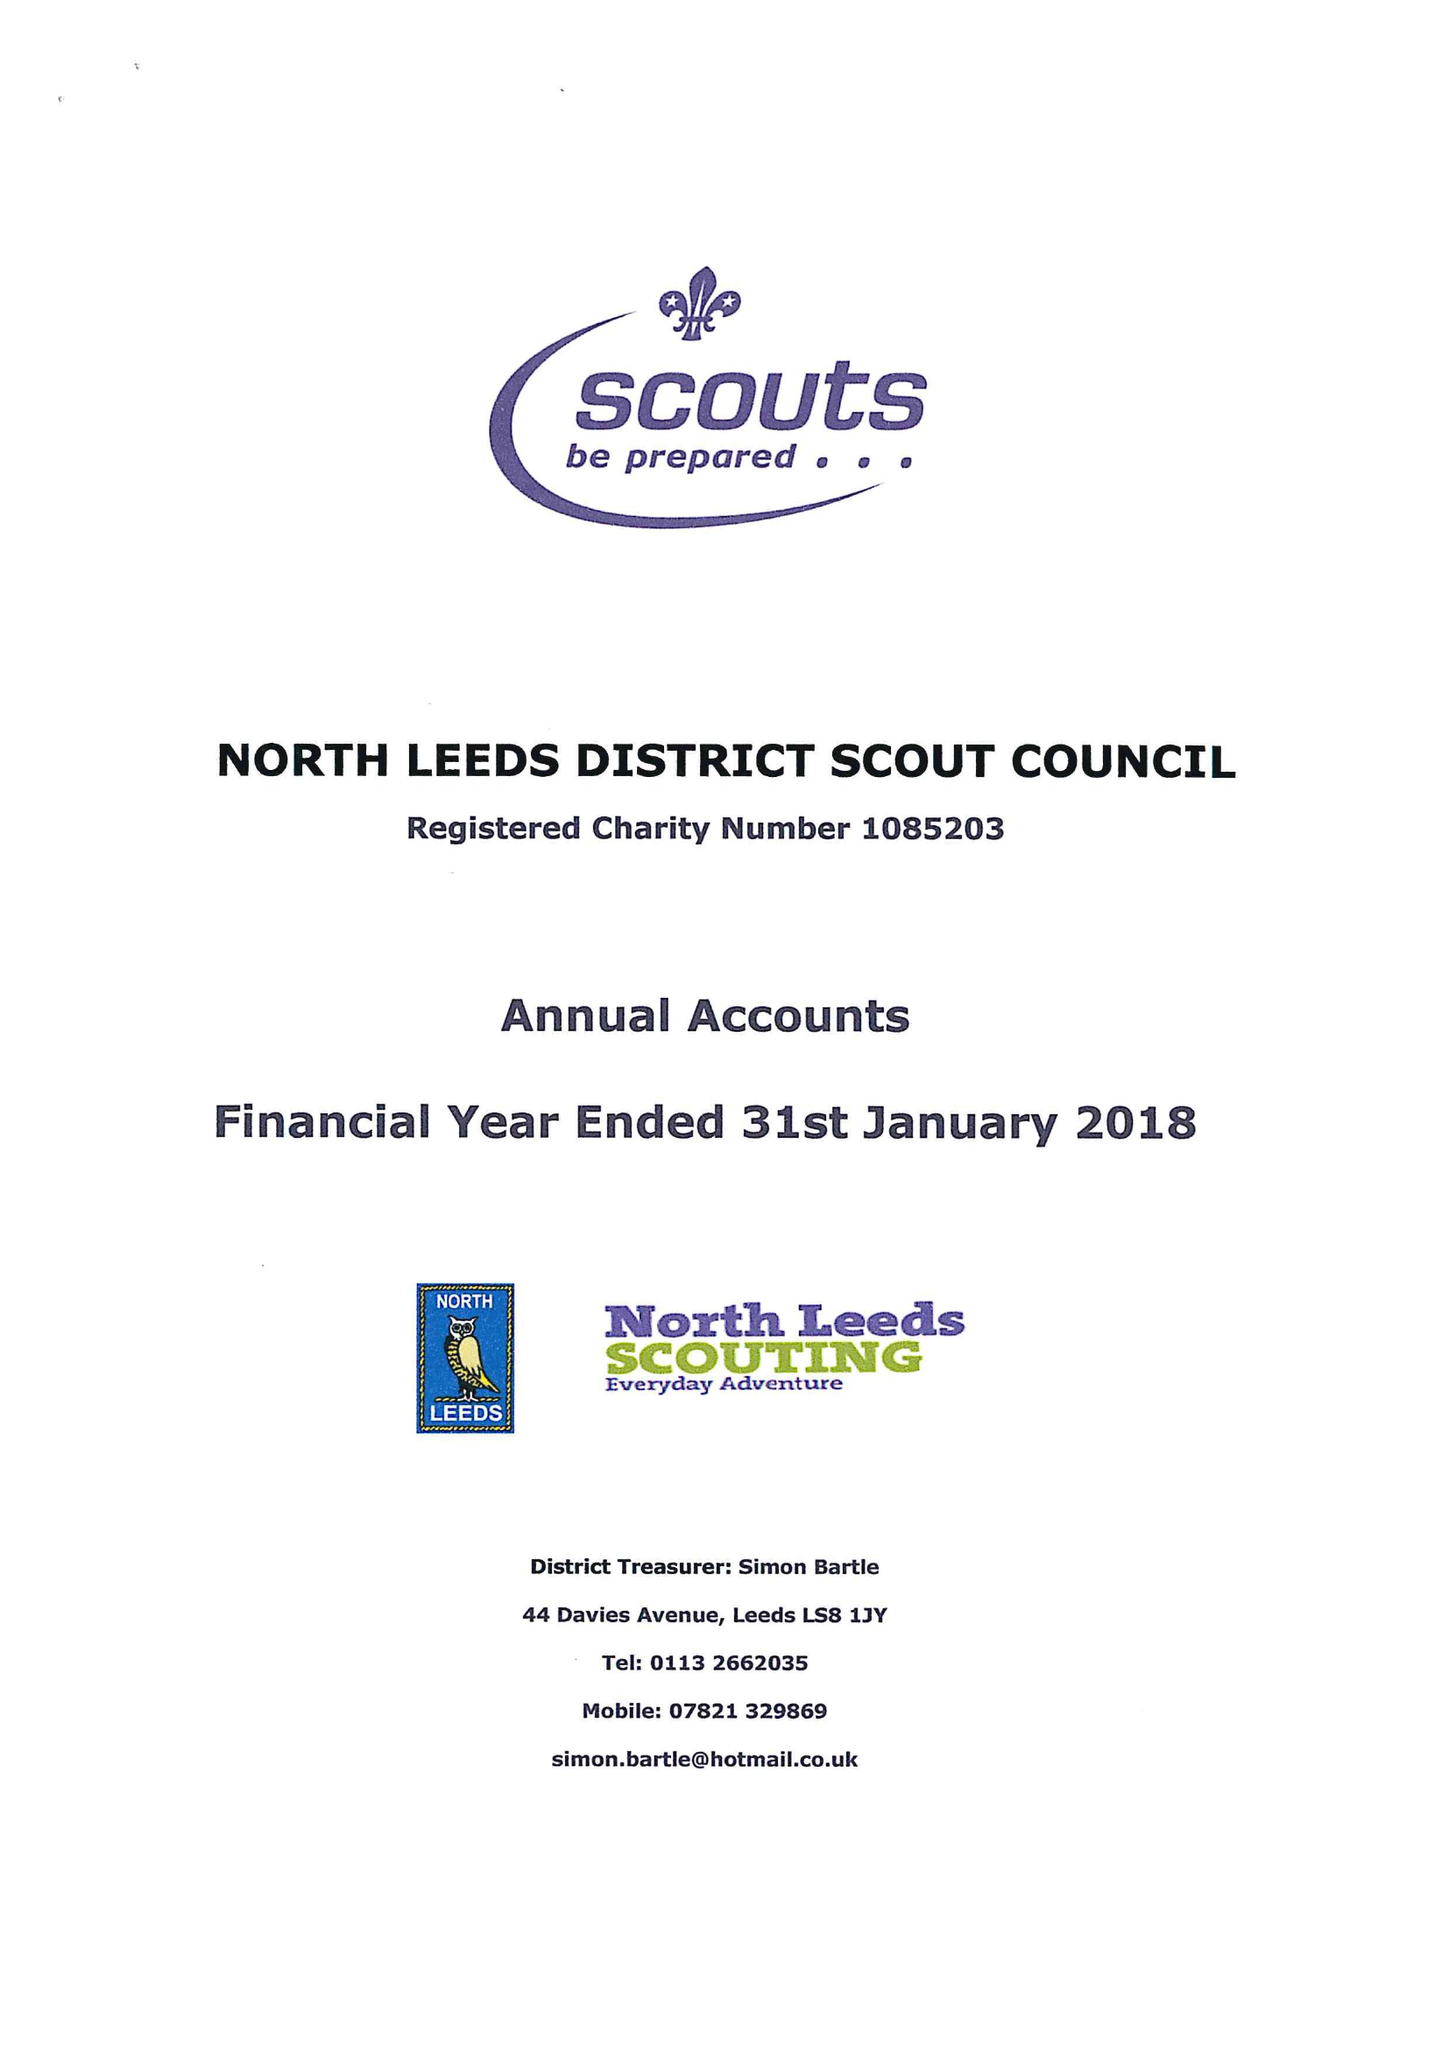What is the value for the address__postcode?
Answer the question using a single word or phrase. LS17 7QP 